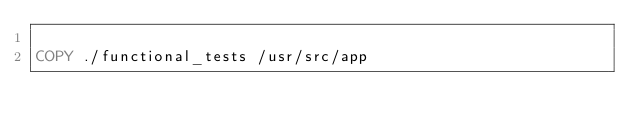<code> <loc_0><loc_0><loc_500><loc_500><_Dockerfile_>
COPY ./functional_tests /usr/src/app
</code> 